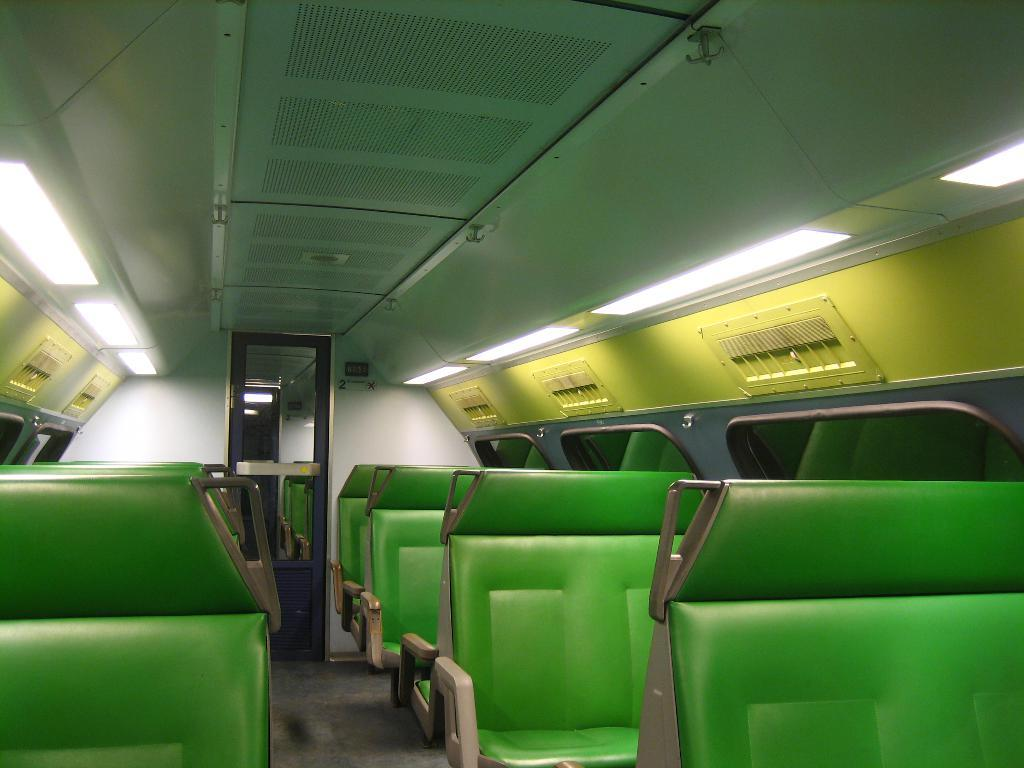What color are the seats in the vehicle depicted in the image? The seats in the image are green. What can be seen on the ceiling of the vehicle? There are lights on the ceiling in the image. What part of a vehicle is shown in the image? The image depicts the inside part of a vehicle. What type of action is the carpenter performing in the image? There is no carpenter present in the image; it depicts the inside of a vehicle with green seats and lights on the ceiling. 